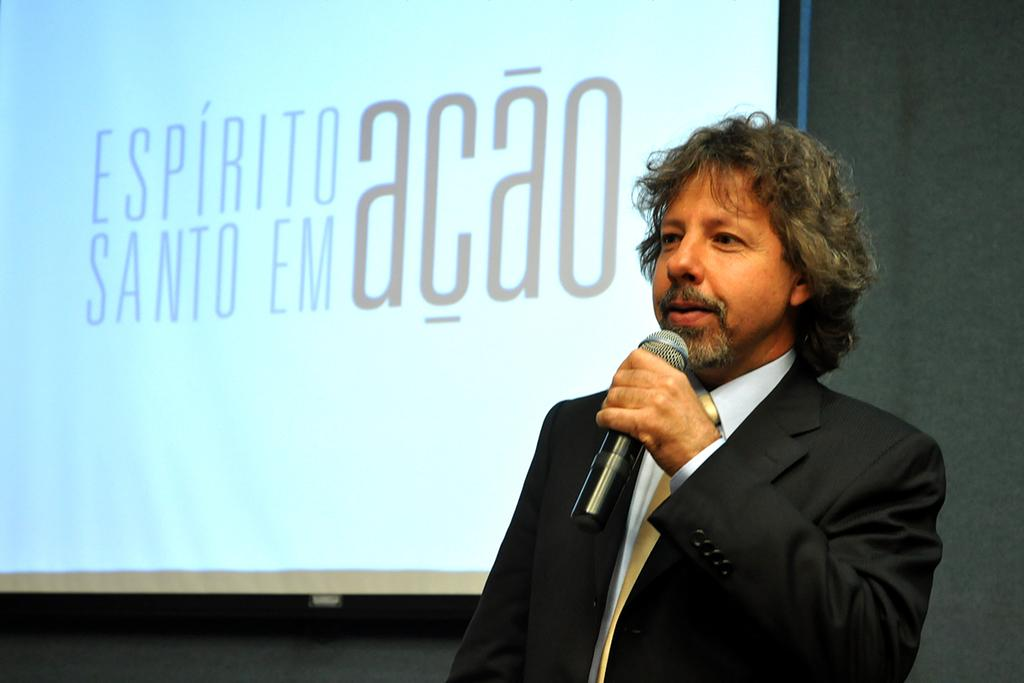Who is the main subject in the image? There is a man in the image. What is the man wearing? The man is wearing a black jacket. What is the man holding in his left hand? The man is holding a mic in his left hand. What can be seen behind the man? There is a screen behind the man. How much profit did the man make from his last performance, as seen in the image? There is no information about the man's performance or profit in the image. 